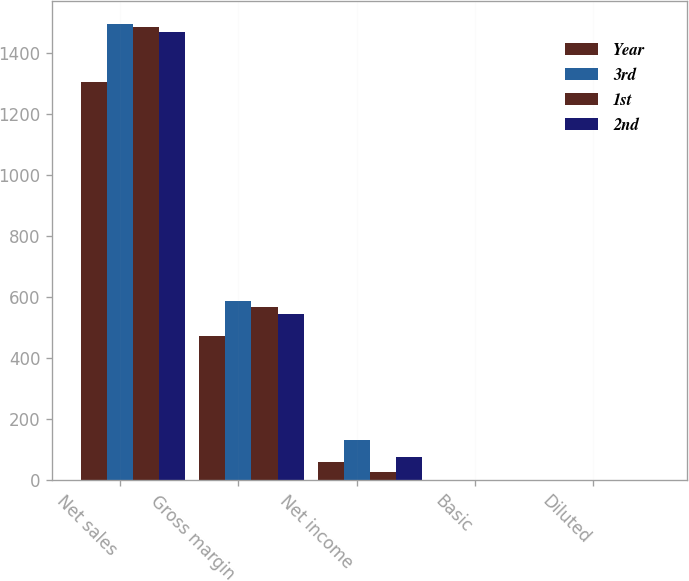Convert chart to OTSL. <chart><loc_0><loc_0><loc_500><loc_500><stacked_bar_chart><ecel><fcel>Net sales<fcel>Gross margin<fcel>Net income<fcel>Basic<fcel>Diluted<nl><fcel>Year<fcel>1306.4<fcel>471.7<fcel>58.4<fcel>0.21<fcel>0.19<nl><fcel>3rd<fcel>1496.2<fcel>587.3<fcel>130.4<fcel>0.46<fcel>0.41<nl><fcel>1st<fcel>1487.3<fcel>567.1<fcel>28.3<fcel>0.1<fcel>0.09<nl><fcel>2nd<fcel>1469.3<fcel>544.7<fcel>75.7<fcel>0.26<fcel>0.25<nl></chart> 